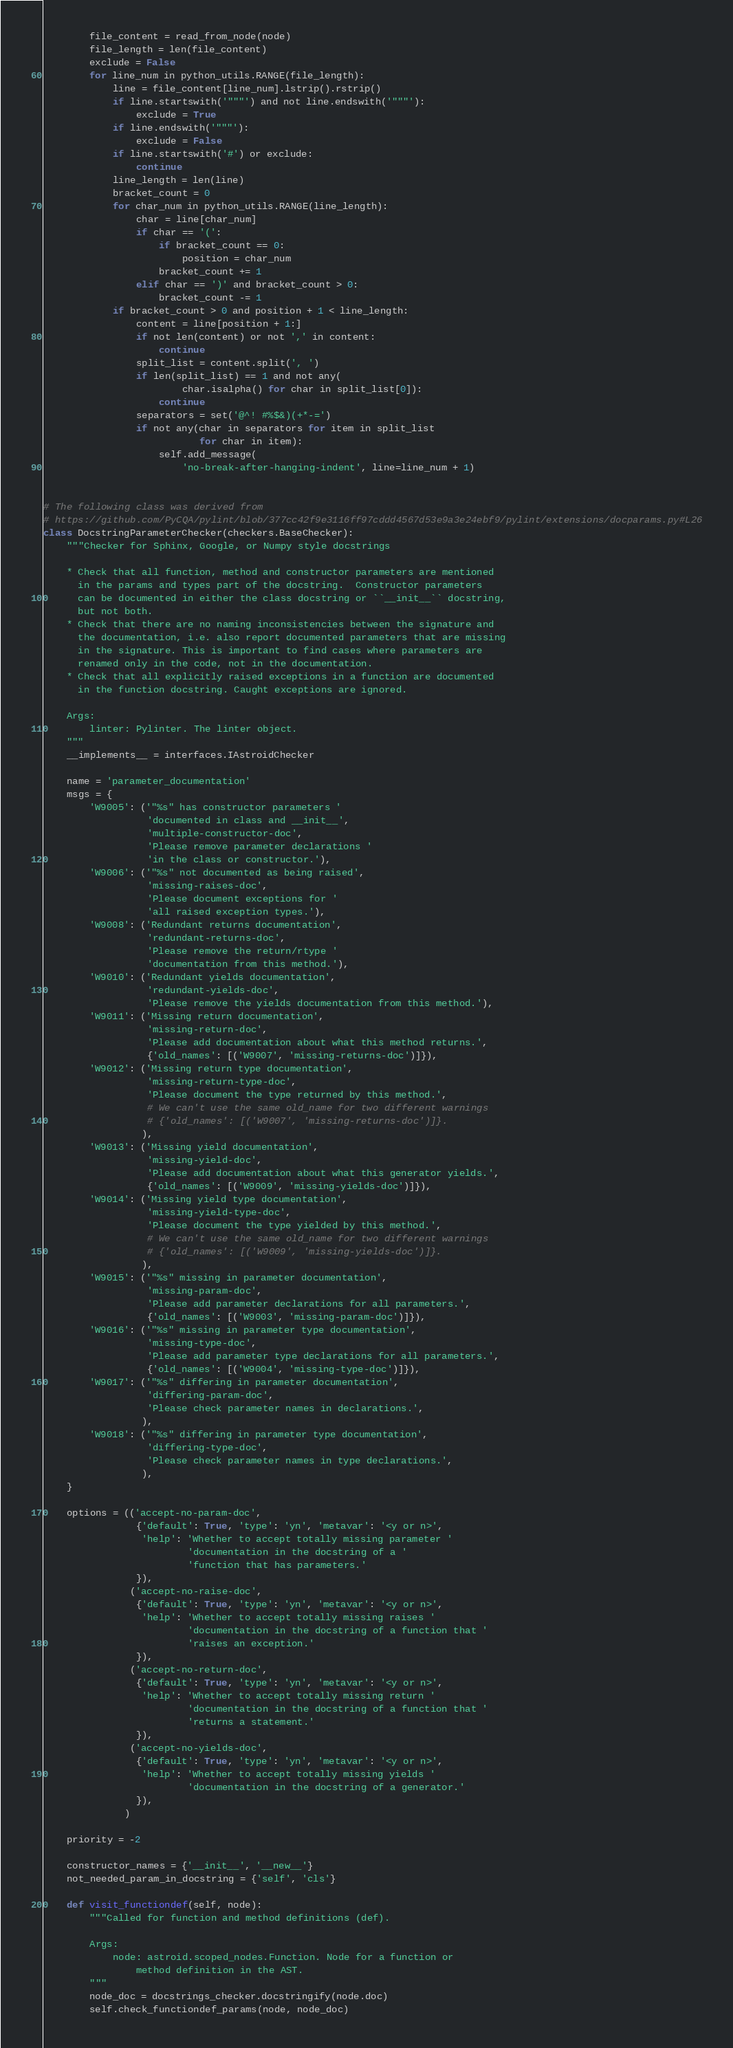Convert code to text. <code><loc_0><loc_0><loc_500><loc_500><_Python_>        file_content = read_from_node(node)
        file_length = len(file_content)
        exclude = False
        for line_num in python_utils.RANGE(file_length):
            line = file_content[line_num].lstrip().rstrip()
            if line.startswith('"""') and not line.endswith('"""'):
                exclude = True
            if line.endswith('"""'):
                exclude = False
            if line.startswith('#') or exclude:
                continue
            line_length = len(line)
            bracket_count = 0
            for char_num in python_utils.RANGE(line_length):
                char = line[char_num]
                if char == '(':
                    if bracket_count == 0:
                        position = char_num
                    bracket_count += 1
                elif char == ')' and bracket_count > 0:
                    bracket_count -= 1
            if bracket_count > 0 and position + 1 < line_length:
                content = line[position + 1:]
                if not len(content) or not ',' in content:
                    continue
                split_list = content.split(', ')
                if len(split_list) == 1 and not any(
                        char.isalpha() for char in split_list[0]):
                    continue
                separators = set('@^! #%$&)(+*-=')
                if not any(char in separators for item in split_list
                           for char in item):
                    self.add_message(
                        'no-break-after-hanging-indent', line=line_num + 1)


# The following class was derived from
# https://github.com/PyCQA/pylint/blob/377cc42f9e3116ff97cddd4567d53e9a3e24ebf9/pylint/extensions/docparams.py#L26
class DocstringParameterChecker(checkers.BaseChecker):
    """Checker for Sphinx, Google, or Numpy style docstrings

    * Check that all function, method and constructor parameters are mentioned
      in the params and types part of the docstring.  Constructor parameters
      can be documented in either the class docstring or ``__init__`` docstring,
      but not both.
    * Check that there are no naming inconsistencies between the signature and
      the documentation, i.e. also report documented parameters that are missing
      in the signature. This is important to find cases where parameters are
      renamed only in the code, not in the documentation.
    * Check that all explicitly raised exceptions in a function are documented
      in the function docstring. Caught exceptions are ignored.

    Args:
        linter: Pylinter. The linter object.
    """
    __implements__ = interfaces.IAstroidChecker

    name = 'parameter_documentation'
    msgs = {
        'W9005': ('"%s" has constructor parameters '
                  'documented in class and __init__',
                  'multiple-constructor-doc',
                  'Please remove parameter declarations '
                  'in the class or constructor.'),
        'W9006': ('"%s" not documented as being raised',
                  'missing-raises-doc',
                  'Please document exceptions for '
                  'all raised exception types.'),
        'W9008': ('Redundant returns documentation',
                  'redundant-returns-doc',
                  'Please remove the return/rtype '
                  'documentation from this method.'),
        'W9010': ('Redundant yields documentation',
                  'redundant-yields-doc',
                  'Please remove the yields documentation from this method.'),
        'W9011': ('Missing return documentation',
                  'missing-return-doc',
                  'Please add documentation about what this method returns.',
                  {'old_names': [('W9007', 'missing-returns-doc')]}),
        'W9012': ('Missing return type documentation',
                  'missing-return-type-doc',
                  'Please document the type returned by this method.',
                  # We can't use the same old_name for two different warnings
                  # {'old_names': [('W9007', 'missing-returns-doc')]}.
                 ),
        'W9013': ('Missing yield documentation',
                  'missing-yield-doc',
                  'Please add documentation about what this generator yields.',
                  {'old_names': [('W9009', 'missing-yields-doc')]}),
        'W9014': ('Missing yield type documentation',
                  'missing-yield-type-doc',
                  'Please document the type yielded by this method.',
                  # We can't use the same old_name for two different warnings
                  # {'old_names': [('W9009', 'missing-yields-doc')]}.
                 ),
        'W9015': ('"%s" missing in parameter documentation',
                  'missing-param-doc',
                  'Please add parameter declarations for all parameters.',
                  {'old_names': [('W9003', 'missing-param-doc')]}),
        'W9016': ('"%s" missing in parameter type documentation',
                  'missing-type-doc',
                  'Please add parameter type declarations for all parameters.',
                  {'old_names': [('W9004', 'missing-type-doc')]}),
        'W9017': ('"%s" differing in parameter documentation',
                  'differing-param-doc',
                  'Please check parameter names in declarations.',
                 ),
        'W9018': ('"%s" differing in parameter type documentation',
                  'differing-type-doc',
                  'Please check parameter names in type declarations.',
                 ),
    }

    options = (('accept-no-param-doc',
                {'default': True, 'type': 'yn', 'metavar': '<y or n>',
                 'help': 'Whether to accept totally missing parameter '
                         'documentation in the docstring of a '
                         'function that has parameters.'
                }),
               ('accept-no-raise-doc',
                {'default': True, 'type': 'yn', 'metavar': '<y or n>',
                 'help': 'Whether to accept totally missing raises '
                         'documentation in the docstring of a function that '
                         'raises an exception.'
                }),
               ('accept-no-return-doc',
                {'default': True, 'type': 'yn', 'metavar': '<y or n>',
                 'help': 'Whether to accept totally missing return '
                         'documentation in the docstring of a function that '
                         'returns a statement.'
                }),
               ('accept-no-yields-doc',
                {'default': True, 'type': 'yn', 'metavar': '<y or n>',
                 'help': 'Whether to accept totally missing yields '
                         'documentation in the docstring of a generator.'
                }),
              )

    priority = -2

    constructor_names = {'__init__', '__new__'}
    not_needed_param_in_docstring = {'self', 'cls'}

    def visit_functiondef(self, node):
        """Called for function and method definitions (def).

        Args:
            node: astroid.scoped_nodes.Function. Node for a function or
                method definition in the AST.
        """
        node_doc = docstrings_checker.docstringify(node.doc)
        self.check_functiondef_params(node, node_doc)</code> 